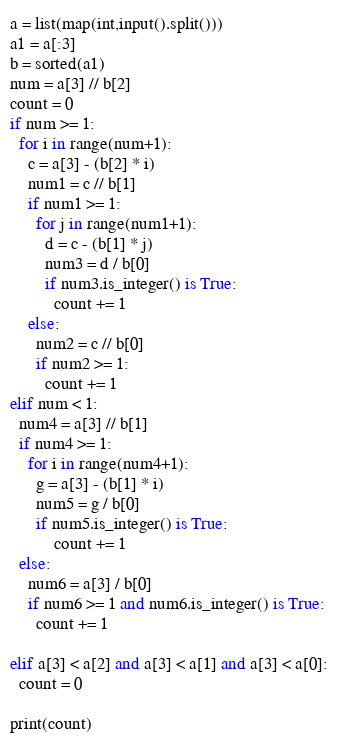Convert code to text. <code><loc_0><loc_0><loc_500><loc_500><_Python_>a = list(map(int,input().split()))
a1 = a[:3]
b = sorted(a1)
num = a[3] // b[2]
count = 0
if num >= 1:
  for i in range(num+1):
    c = a[3] - (b[2] * i)
    num1 = c // b[1]
    if num1 >= 1:
      for j in range(num1+1):
        d = c - (b[1] * j)
        num3 = d / b[0]
        if num3.is_integer() is True:
          count += 1
    else:
      num2 = c // b[0]
      if num2 >= 1:
        count += 1
elif num < 1:
  num4 = a[3] // b[1]
  if num4 >= 1:
    for i in range(num4+1):
      g = a[3] - (b[1] * i)
      num5 = g / b[0]
      if num5.is_integer() is True:
          count += 1
  else:
    num6 = a[3] / b[0]
    if num6 >= 1 and num6.is_integer() is True:
      count += 1
      
elif a[3] < a[2] and a[3] < a[1] and a[3] < a[0]:
  count = 0
  
print(count)</code> 